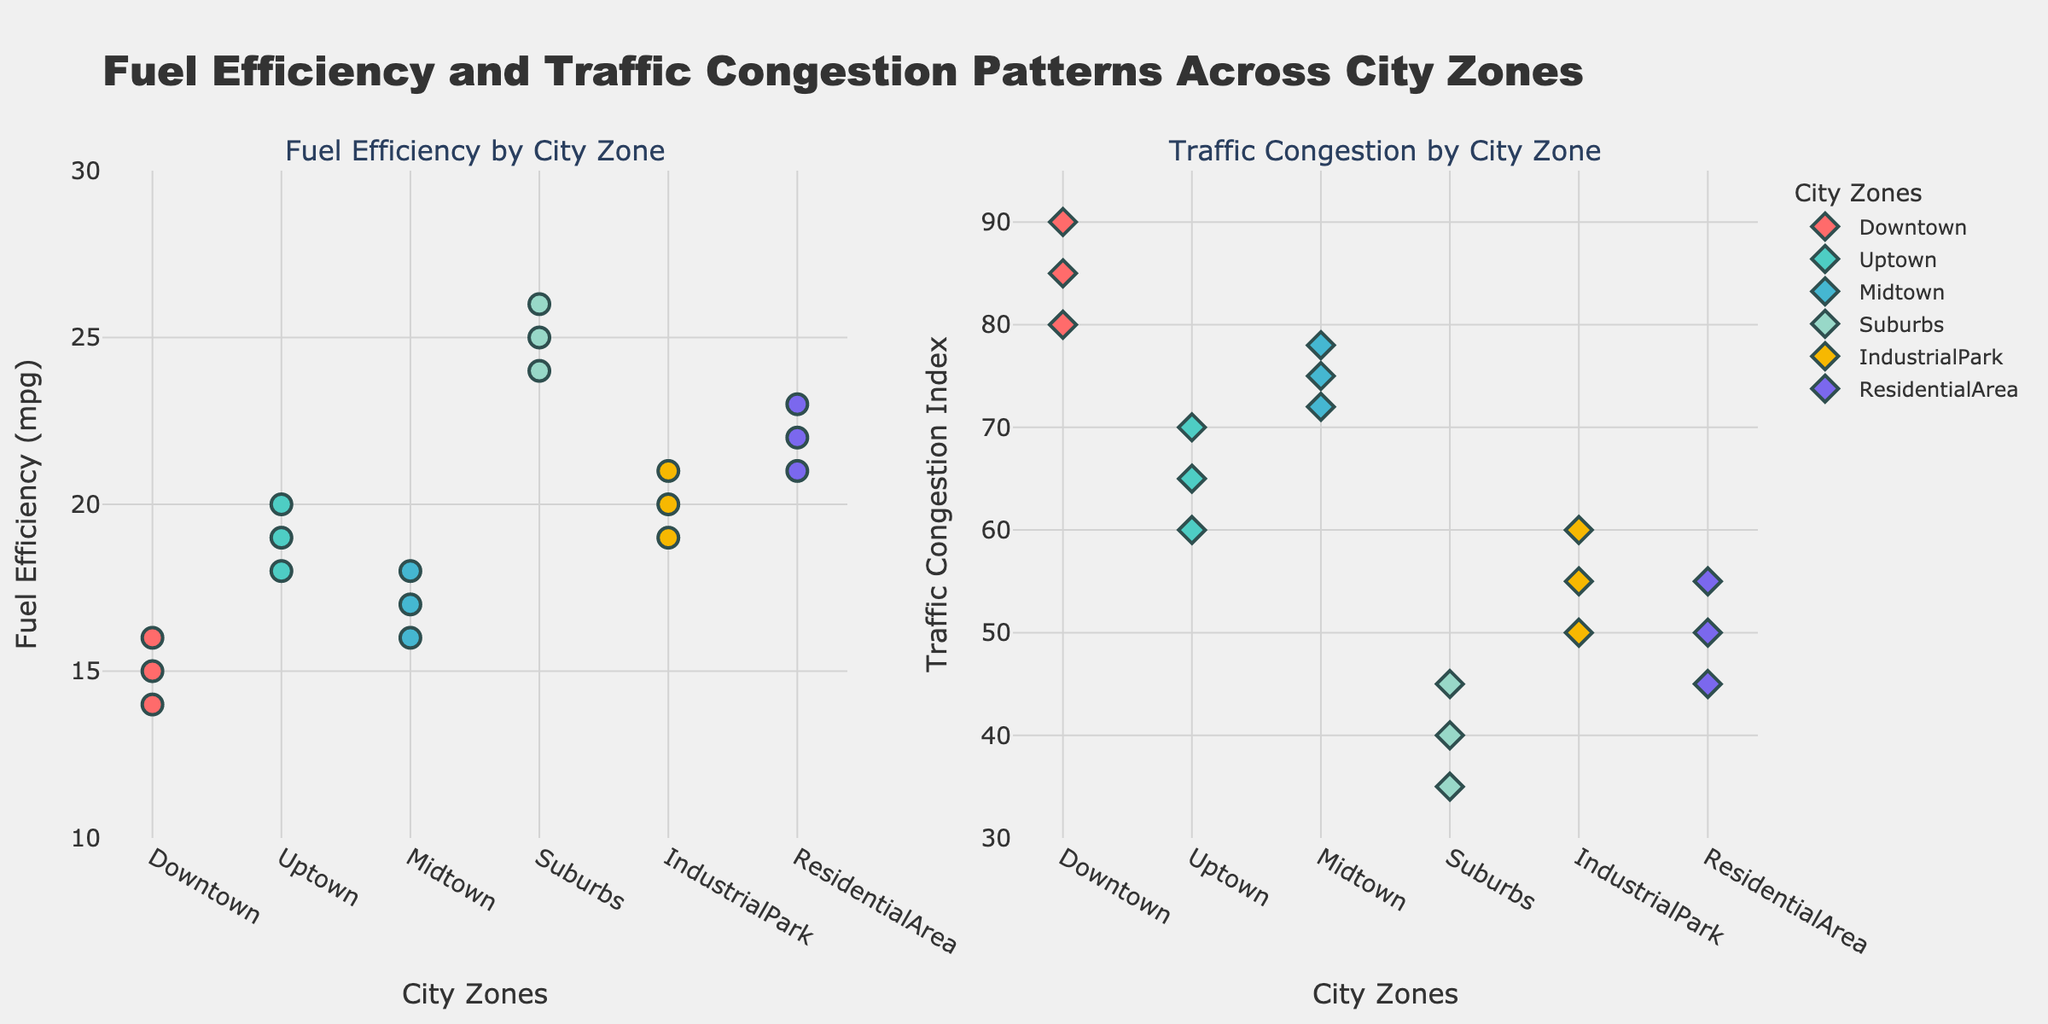What's the title of the figure? The title is located at the top center of the figure. It provides a summary of what the figure represents.
Answer: Fuel Efficiency and Traffic Congestion Patterns Across City Zones Which city zone has the highest average fuel efficiency? By looking at the left subplot, observe the vertical spread of dots for each zone. The "Suburbs" zone has dots situated higher on the y-axis, indicating higher average fuel efficiency compared to other zones.
Answer: Suburbs Is the traffic congestion index higher in Downtown or in Uptown? By examining the right subplot, compare the placement of the dots for "Downtown" and "Uptown." The dots for "Downtown" are generally higher on the y-axis than those for "Uptown."
Answer: Downtown How many city zones are displayed in the plots? Count the distinct labels or categories on the x-axis of both subplots to determine the number of different city zones shown.
Answer: 6 What is the range of traffic congestion index values shown for the IndustrialPark? Locate the "IndustrialPark" dots in the right subplot. Identify the lowest and highest positions on the y-axis for these dots. The lowest value is 50 and the highest value is 60.
Answer: 50 to 60 Compare the fuel efficiency in Midtown and ResidentialArea. Which has a greater range? Look at the vertical span of dots in the left subplot for both "Midtown" and "ResidentialArea." The "Midtown" dots range from 16 to 18, while the "ResidentialArea" dots range from 21 to 23. Midtown has a range of 2, while ResidentialArea has a range of 2.
Answer: ResidentialArea Which city zone shows the least traffic congestion? Identify the city zone whose dots are positioned lowest on the y-axis in the right subplot. "Suburbs" has dots lowest with values ranging from 35 to 45.
Answer: Suburbs What is the difference in maximum fuel efficiency between Uptown and Downtown? Identify the highest positioned dot for both "Uptown" and "Downtown" in the left subplot. The highest fuel efficiency in "Uptown" is 20 mpg, and for "Downtown" it is 16 mpg. The difference is 20 - 16 = 4 mpg.
Answer: 4 mpg 